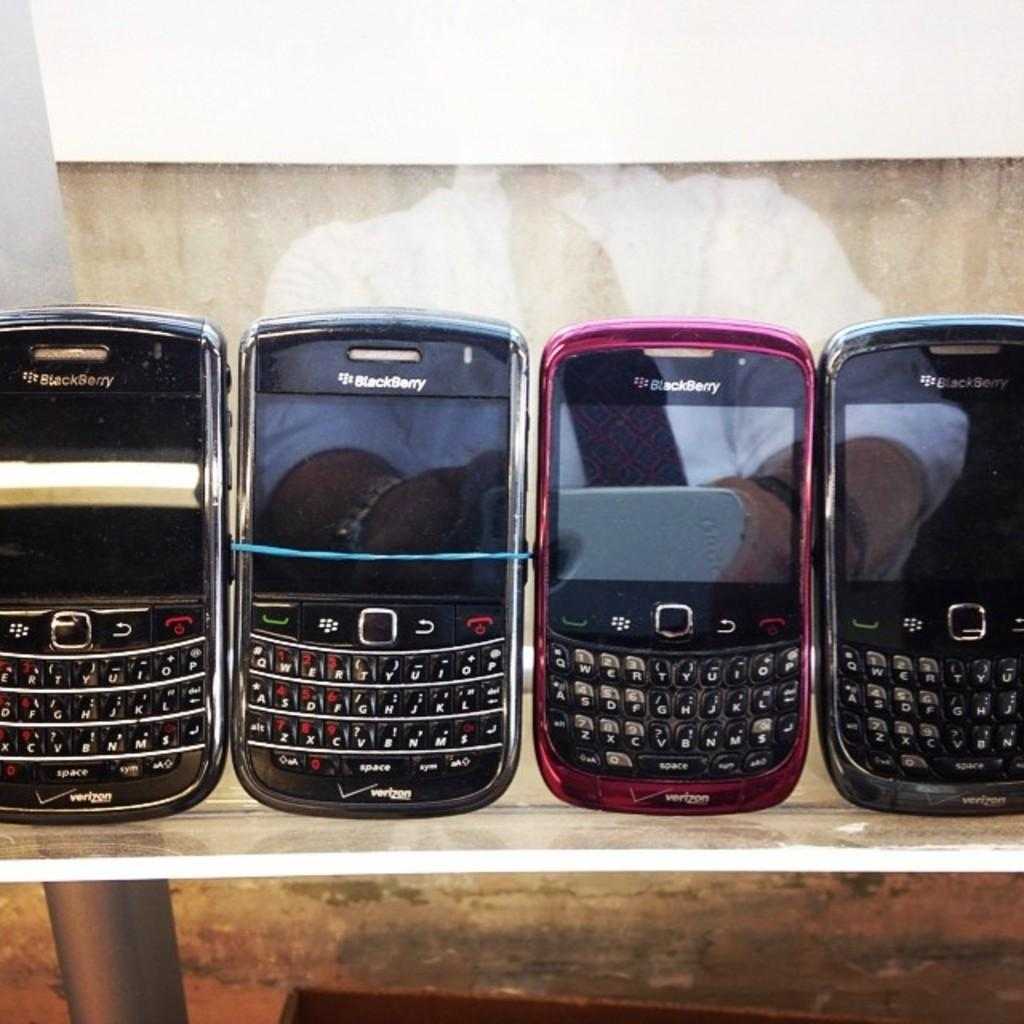<image>
Create a compact narrative representing the image presented. a Blackberry phone that is among many other phones 